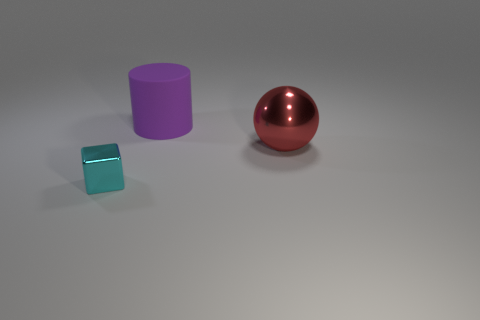Is there any other thing that is made of the same material as the large purple cylinder?
Your answer should be very brief. No. Does the matte object have the same size as the object right of the purple cylinder?
Offer a terse response. Yes. There is a metal object that is behind the object in front of the red metal object; is there a shiny thing that is left of it?
Your answer should be very brief. Yes. What is the large thing behind the metal thing that is behind the tiny metal object made of?
Make the answer very short. Rubber. There is a object that is to the left of the large red object and to the right of the metallic block; what is it made of?
Your answer should be compact. Rubber. Are there any objects that are left of the shiny object behind the cyan metal block?
Offer a terse response. Yes. How many big red things have the same material as the small cyan block?
Ensure brevity in your answer.  1. Is there a red block?
Offer a very short reply. No. How many large matte things have the same color as the big metallic ball?
Keep it short and to the point. 0. Do the large red sphere and the big thing that is left of the big metallic sphere have the same material?
Ensure brevity in your answer.  No. 